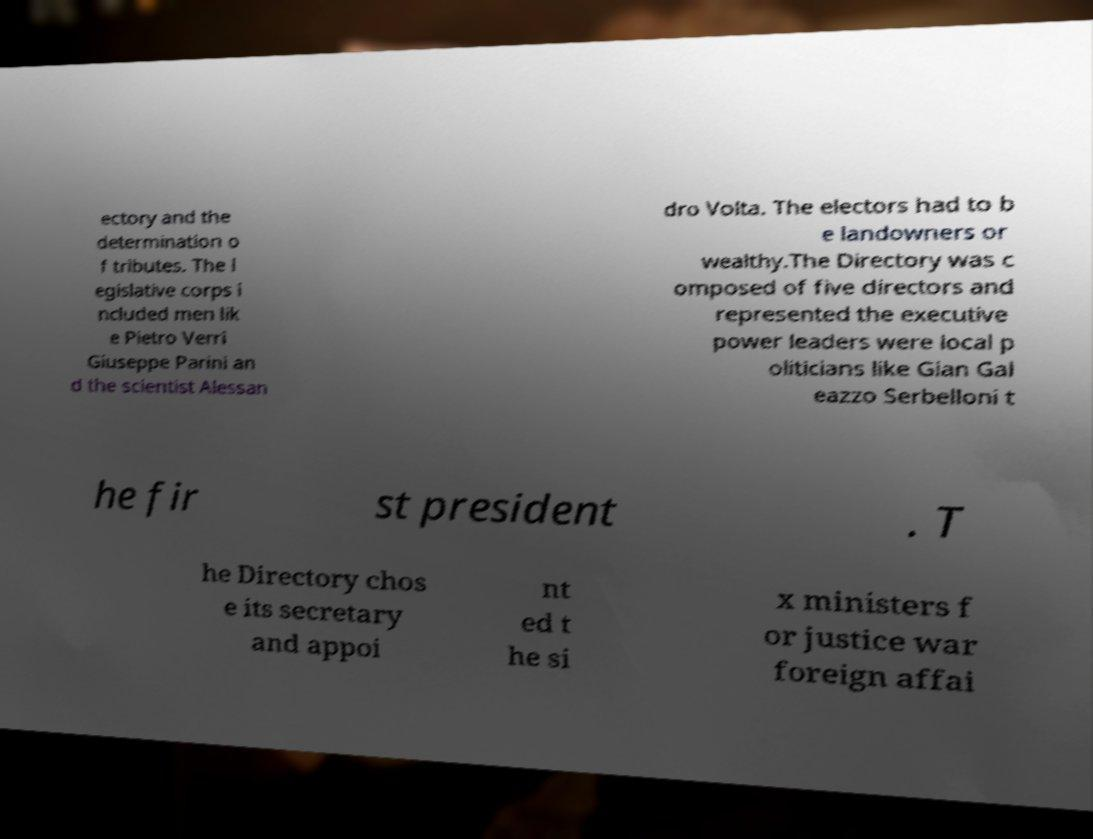Can you accurately transcribe the text from the provided image for me? ectory and the determination o f tributes. The l egislative corps i ncluded men lik e Pietro Verri Giuseppe Parini an d the scientist Alessan dro Volta. The electors had to b e landowners or wealthy.The Directory was c omposed of five directors and represented the executive power leaders were local p oliticians like Gian Gal eazzo Serbelloni t he fir st president . T he Directory chos e its secretary and appoi nt ed t he si x ministers f or justice war foreign affai 